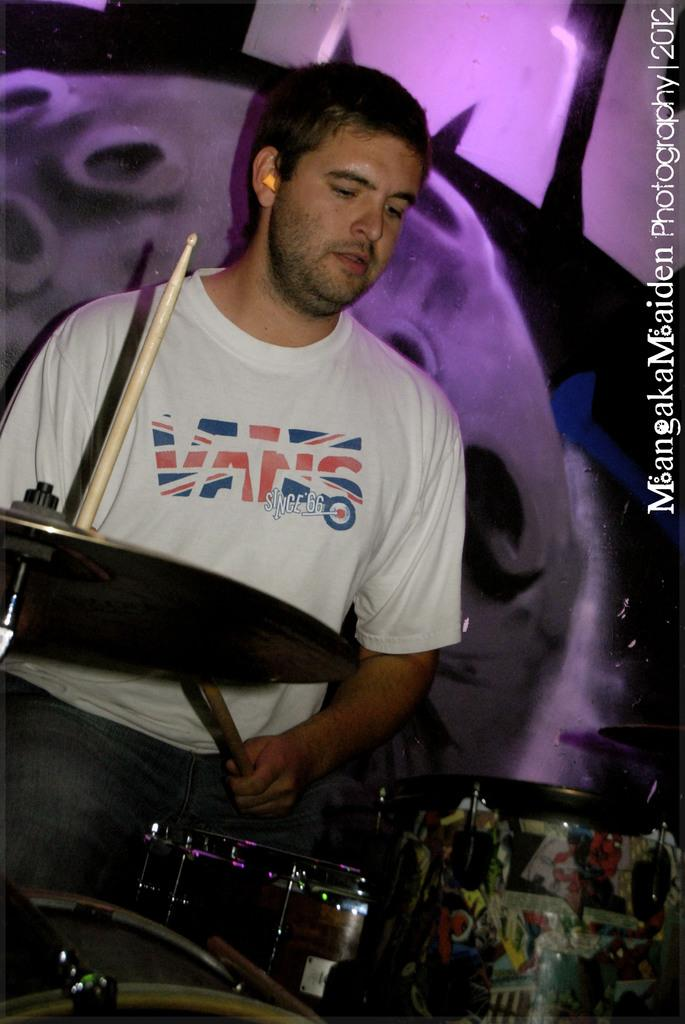What is the man in the image doing? The man is playing drums. What is the man wearing in the image? The man is wearing a white shirt and pants. What is the man holding in the image? The man is holding drumsticks. What color is the background of the image? The background of the image is purple. Can you see any steam coming from the man's clothes in the image? There is no steam visible in the image. Is there a receipt for the drum purchase in the image? There is no receipt present in the image. 